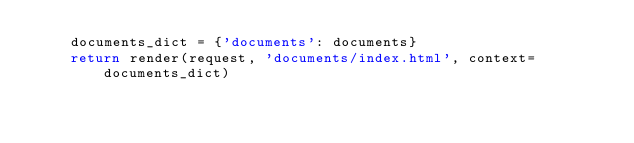<code> <loc_0><loc_0><loc_500><loc_500><_Python_>    documents_dict = {'documents': documents}
    return render(request, 'documents/index.html', context=documents_dict)</code> 